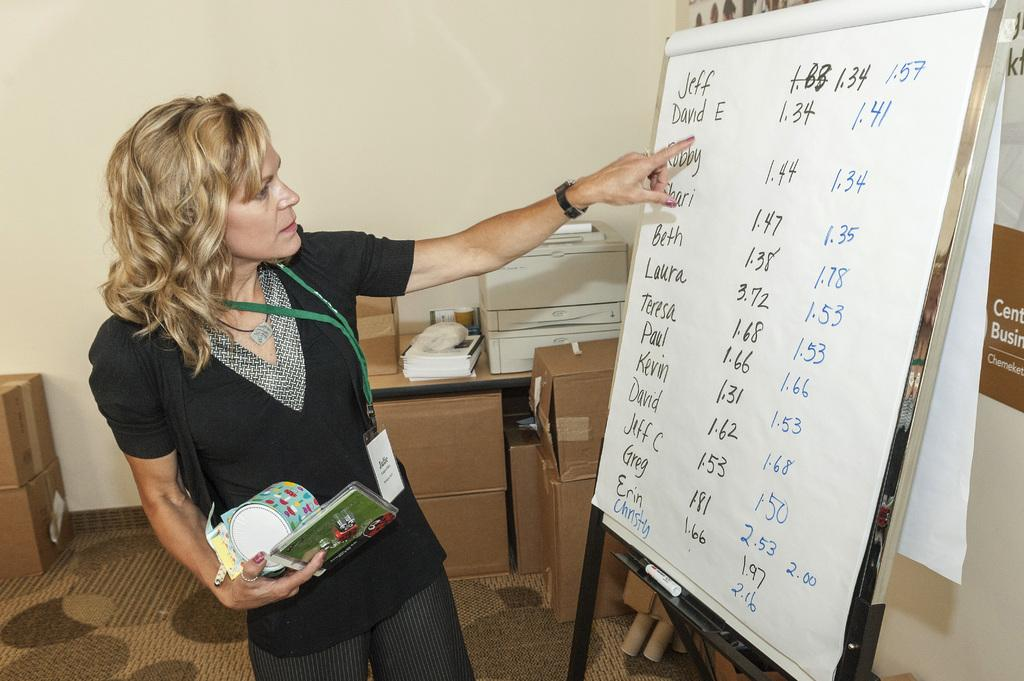<image>
Relay a brief, clear account of the picture shown. A lady standing next to a piece of paper with the number 150 on it. 